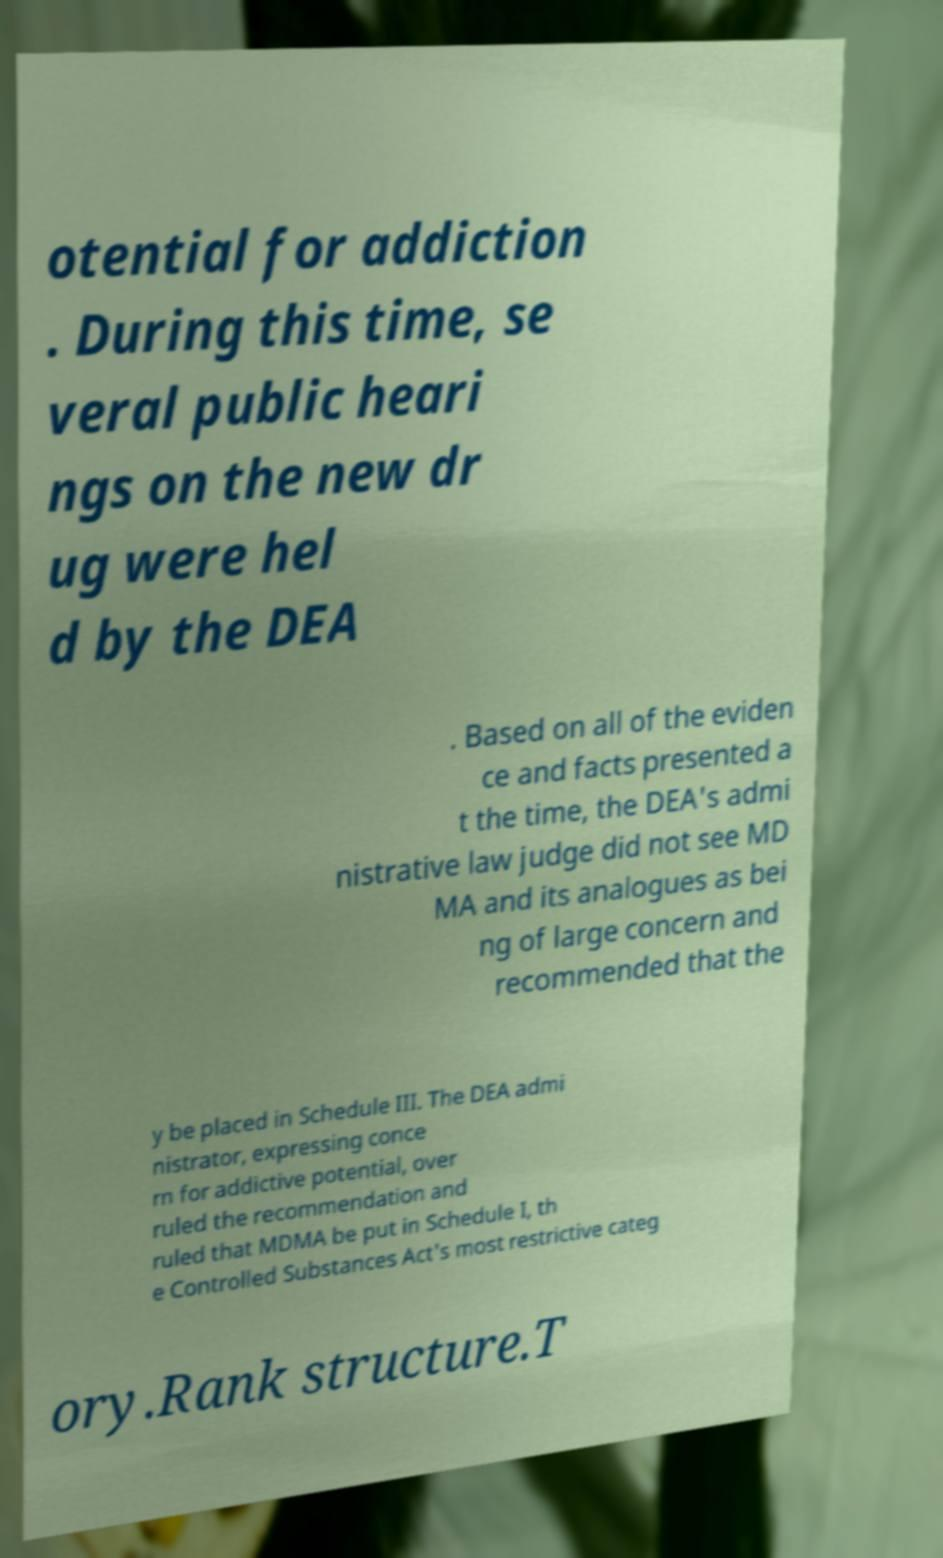Could you extract and type out the text from this image? otential for addiction . During this time, se veral public heari ngs on the new dr ug were hel d by the DEA . Based on all of the eviden ce and facts presented a t the time, the DEA's admi nistrative law judge did not see MD MA and its analogues as bei ng of large concern and recommended that the y be placed in Schedule III. The DEA admi nistrator, expressing conce rn for addictive potential, over ruled the recommendation and ruled that MDMA be put in Schedule I, th e Controlled Substances Act's most restrictive categ ory.Rank structure.T 